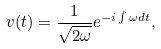<formula> <loc_0><loc_0><loc_500><loc_500>v ( t ) = \frac { 1 } { \sqrt { 2 \omega } } e ^ { - i \int \omega d t } ,</formula> 